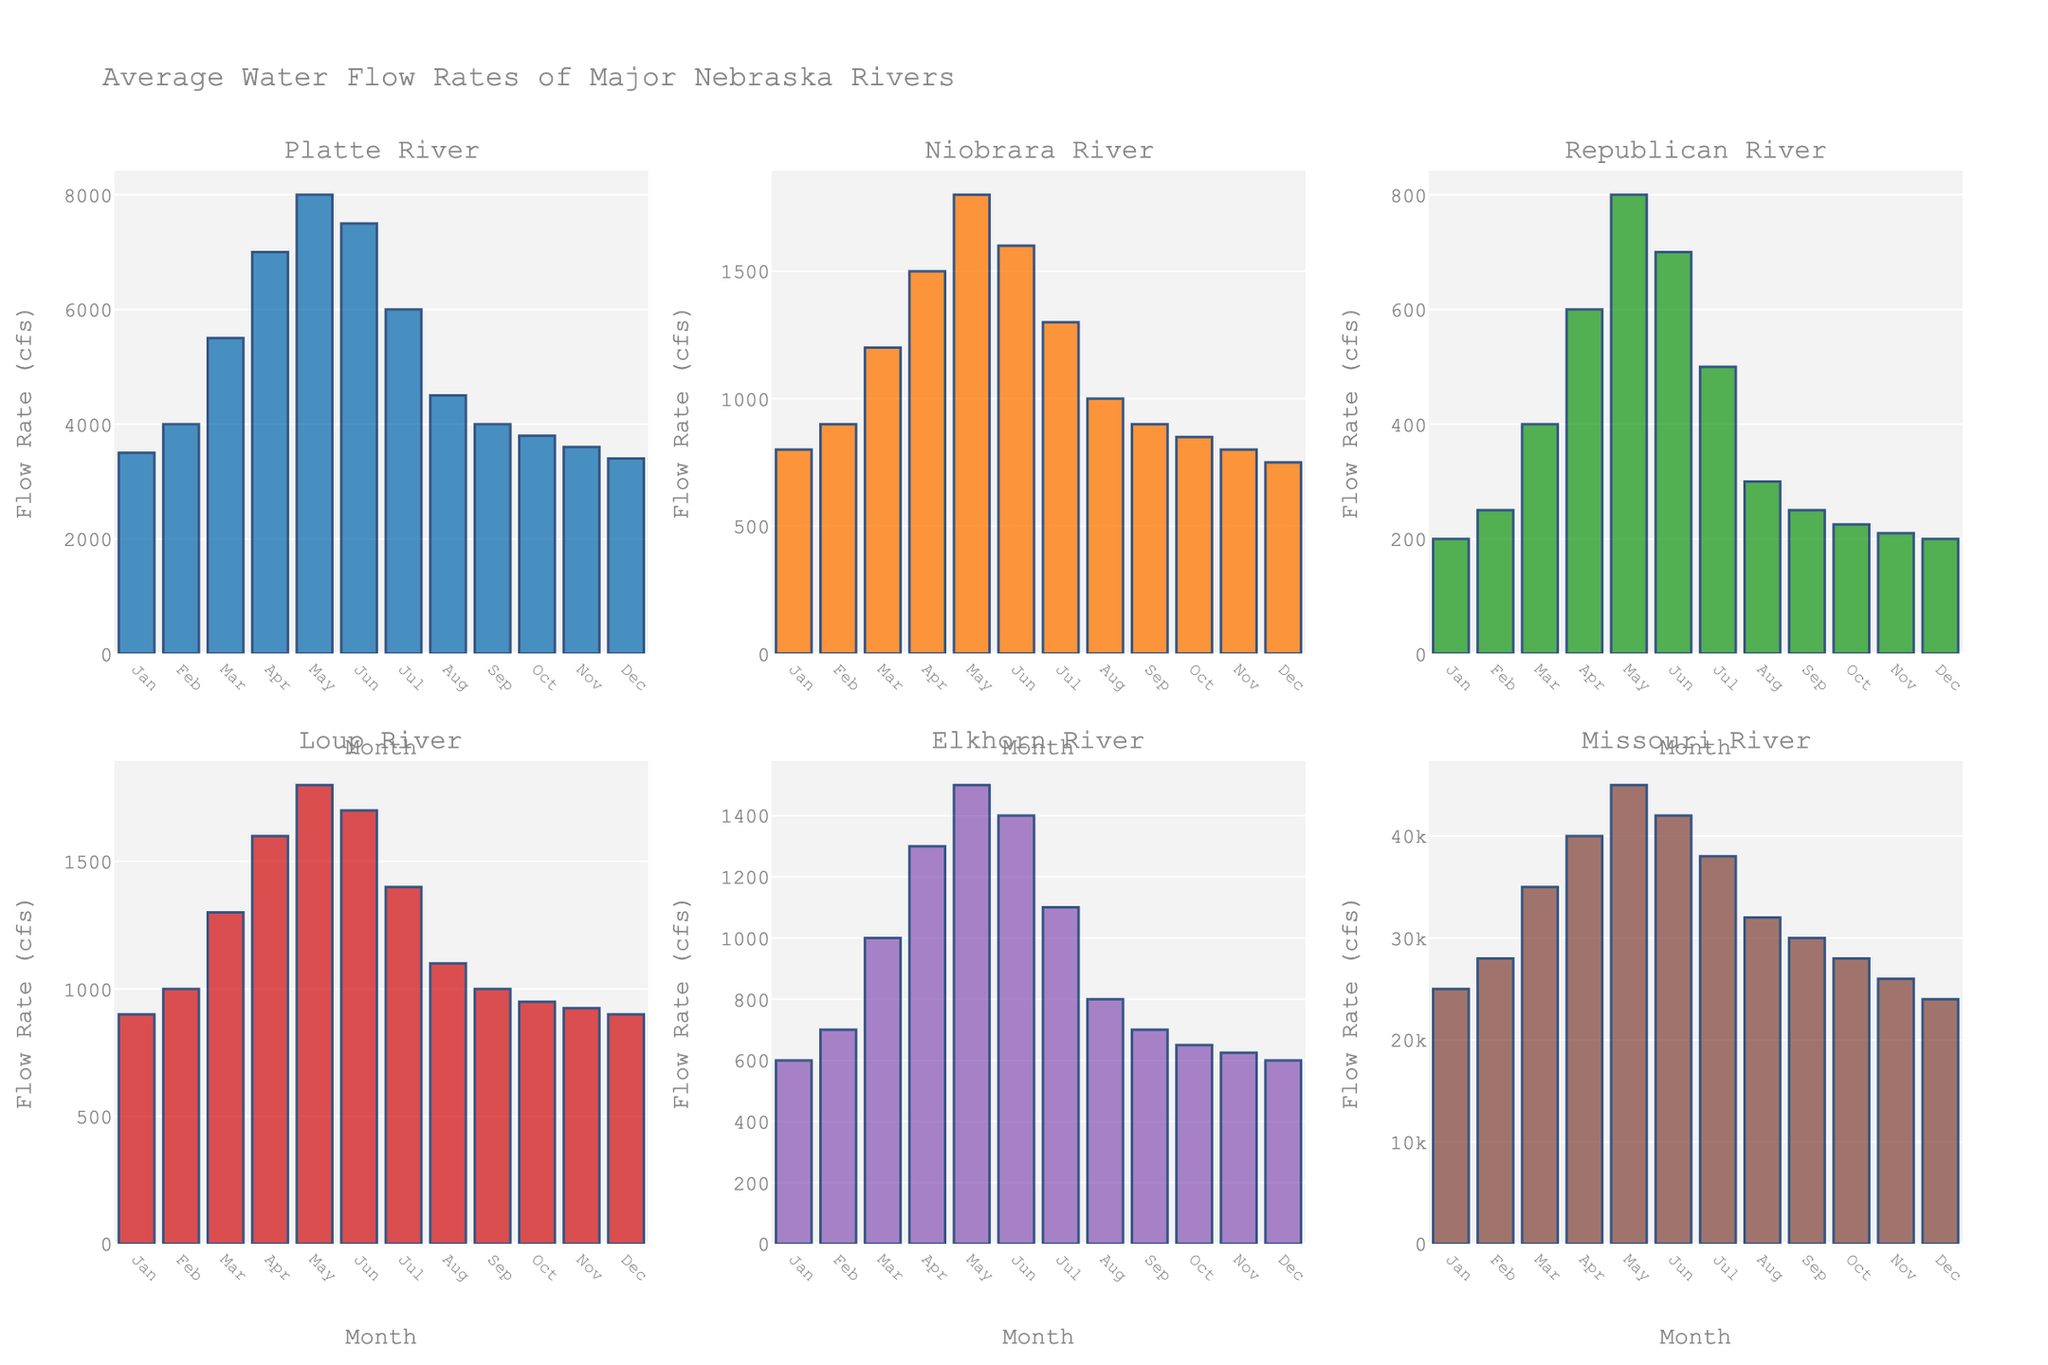what is the lowest water flow rate of the Niobrara River and in which month does it occur? Observing the heights of the bars in the subplot for the Niobrara River, the lowest bar is in the month of December with a value of 750 cfs.
Answer: December, 750 cfs which river has the highest flow rate in May and what is it? Comparing the heights of the bars in May across all subplots, the Missouri River's bar is the tallest, indicating the highest flow rate of 45000 cfs.
Answer: Missouri River, 45000 cfs what's the average flow rate of the Platte River from January to June? For the Platte River subplot, sum the values from January to June (3500 + 4000 + 5500 + 7000 + 8000 + 7500 = 35500 cfs), then divide by 6 (35500 / 6 ≈ 5917 cfs).
Answer: 5917 cfs which two rivers have similar water flow rates in August? Observing the heights of the bars for August, both the Niobrara River and Platte River have bars with similar heights around 1000 cfs and 4500 cfs respectively.
Answer: Niobrara River and Platte River in which month does the Elkhorn River have the highest flow rate and what is it? Observing the heights of the bars for the Elkhorn River, the highest bar is in May with a value of 1500 cfs.
Answer: May, 1500 cfs how does the Loup River's flow rate in July compare to the Niobrara River's in the same month? Comparing the heights of the bars for July in both subplots, the Loup River (1400 cfs) has a higher flow rate than the Niobrara River (1200 cfs).
Answer: Loup River's rate is higher what is the total flow rate of the Republican River for the first half of the year? Summing the values from January to June for the Republican River: 200 + 250 + 400 + 600 + 800 + 700 = 2950 cfs.
Answer: 2950 cfs which river has the least variation in flow rates throughout the year? Observing all subplots, the Niobrara River's bars show the least variation in heights, indicating the least variation in flow rates.
Answer: Niobrara River what is the difference in flow rate between the Missouri River in June and the Platte River in June? Observing the heights of the bars for June, the Missouri River (42000 cfs) and the Platte River (7500 cfs) have a difference of 42000 - 7500 = 34500 cfs.
Answer: 34500 cfs 